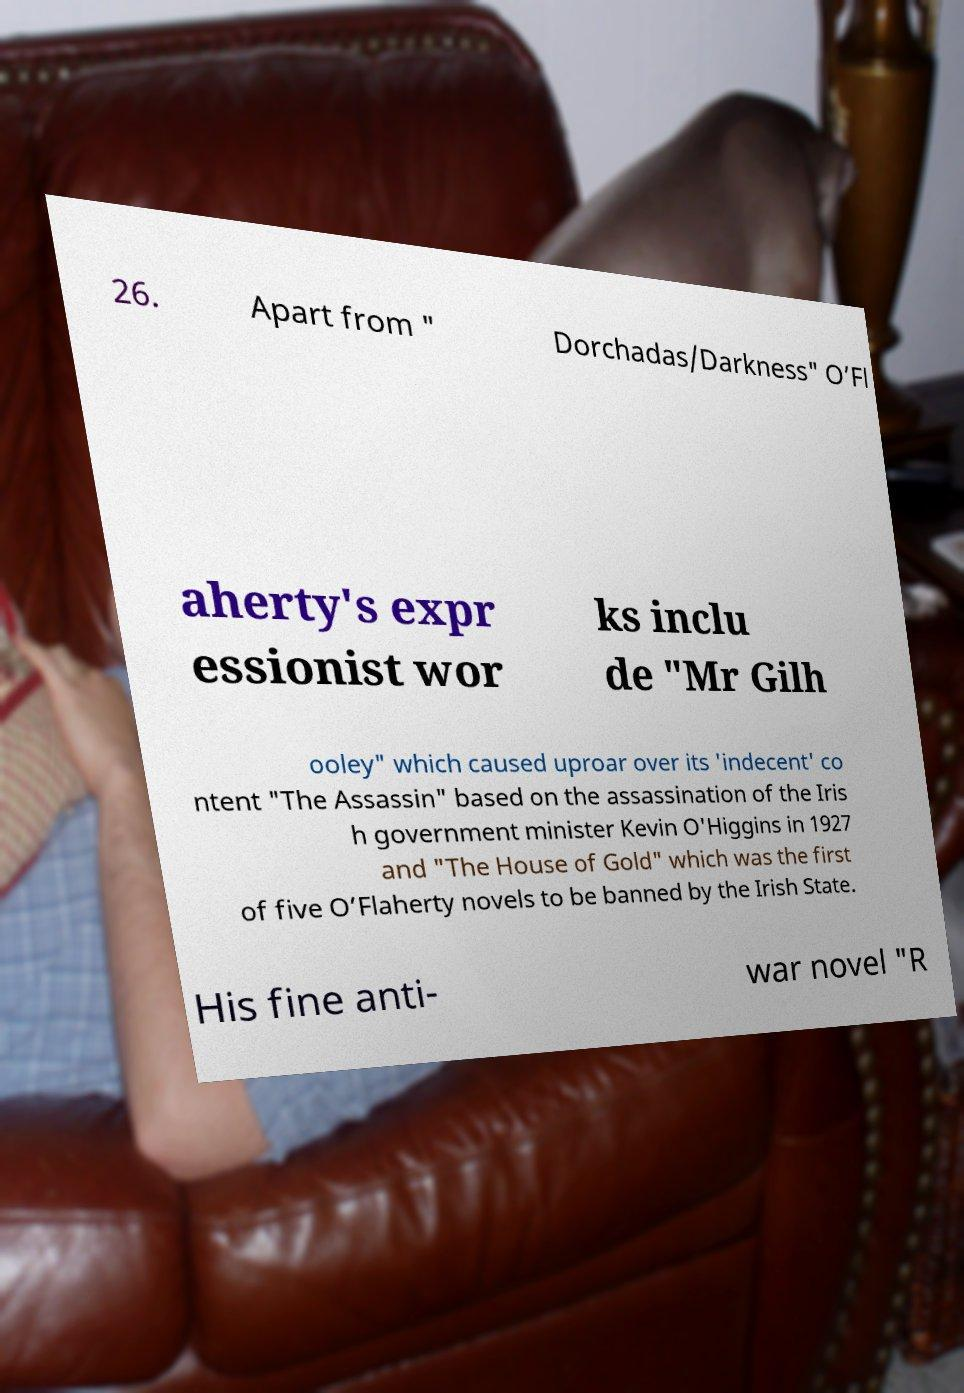What messages or text are displayed in this image? I need them in a readable, typed format. 26. Apart from " Dorchadas/Darkness" O’Fl aherty's expr essionist wor ks inclu de "Mr Gilh ooley" which caused uproar over its 'indecent' co ntent "The Assassin" based on the assassination of the Iris h government minister Kevin O'Higgins in 1927 and "The House of Gold" which was the first of five O’Flaherty novels to be banned by the Irish State. His fine anti- war novel "R 